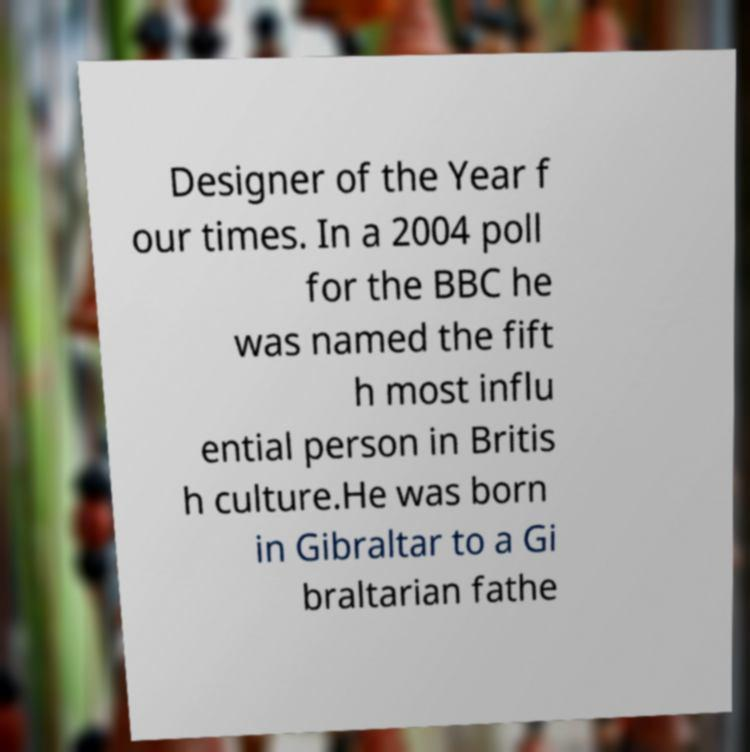Can you accurately transcribe the text from the provided image for me? Designer of the Year f our times. In a 2004 poll for the BBC he was named the fift h most influ ential person in Britis h culture.He was born in Gibraltar to a Gi braltarian fathe 